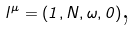Convert formula to latex. <formula><loc_0><loc_0><loc_500><loc_500>l ^ { \mu } = ( 1 , N , \omega , 0 ) \text {,}</formula> 